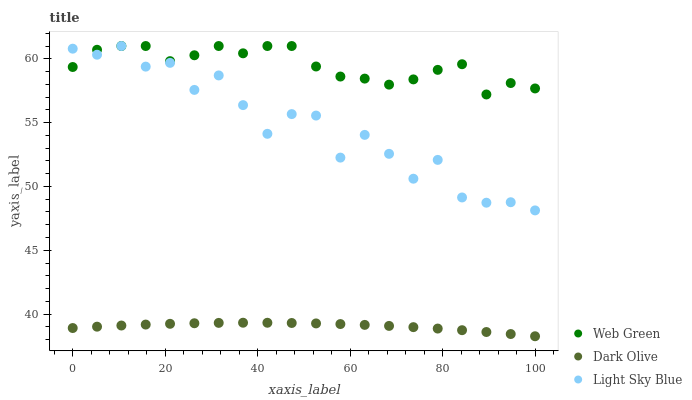Does Dark Olive have the minimum area under the curve?
Answer yes or no. Yes. Does Web Green have the maximum area under the curve?
Answer yes or no. Yes. Does Light Sky Blue have the minimum area under the curve?
Answer yes or no. No. Does Light Sky Blue have the maximum area under the curve?
Answer yes or no. No. Is Dark Olive the smoothest?
Answer yes or no. Yes. Is Light Sky Blue the roughest?
Answer yes or no. Yes. Is Web Green the smoothest?
Answer yes or no. No. Is Web Green the roughest?
Answer yes or no. No. Does Dark Olive have the lowest value?
Answer yes or no. Yes. Does Light Sky Blue have the lowest value?
Answer yes or no. No. Does Light Sky Blue have the highest value?
Answer yes or no. Yes. Is Dark Olive less than Light Sky Blue?
Answer yes or no. Yes. Is Web Green greater than Dark Olive?
Answer yes or no. Yes. Does Light Sky Blue intersect Web Green?
Answer yes or no. Yes. Is Light Sky Blue less than Web Green?
Answer yes or no. No. Is Light Sky Blue greater than Web Green?
Answer yes or no. No. Does Dark Olive intersect Light Sky Blue?
Answer yes or no. No. 